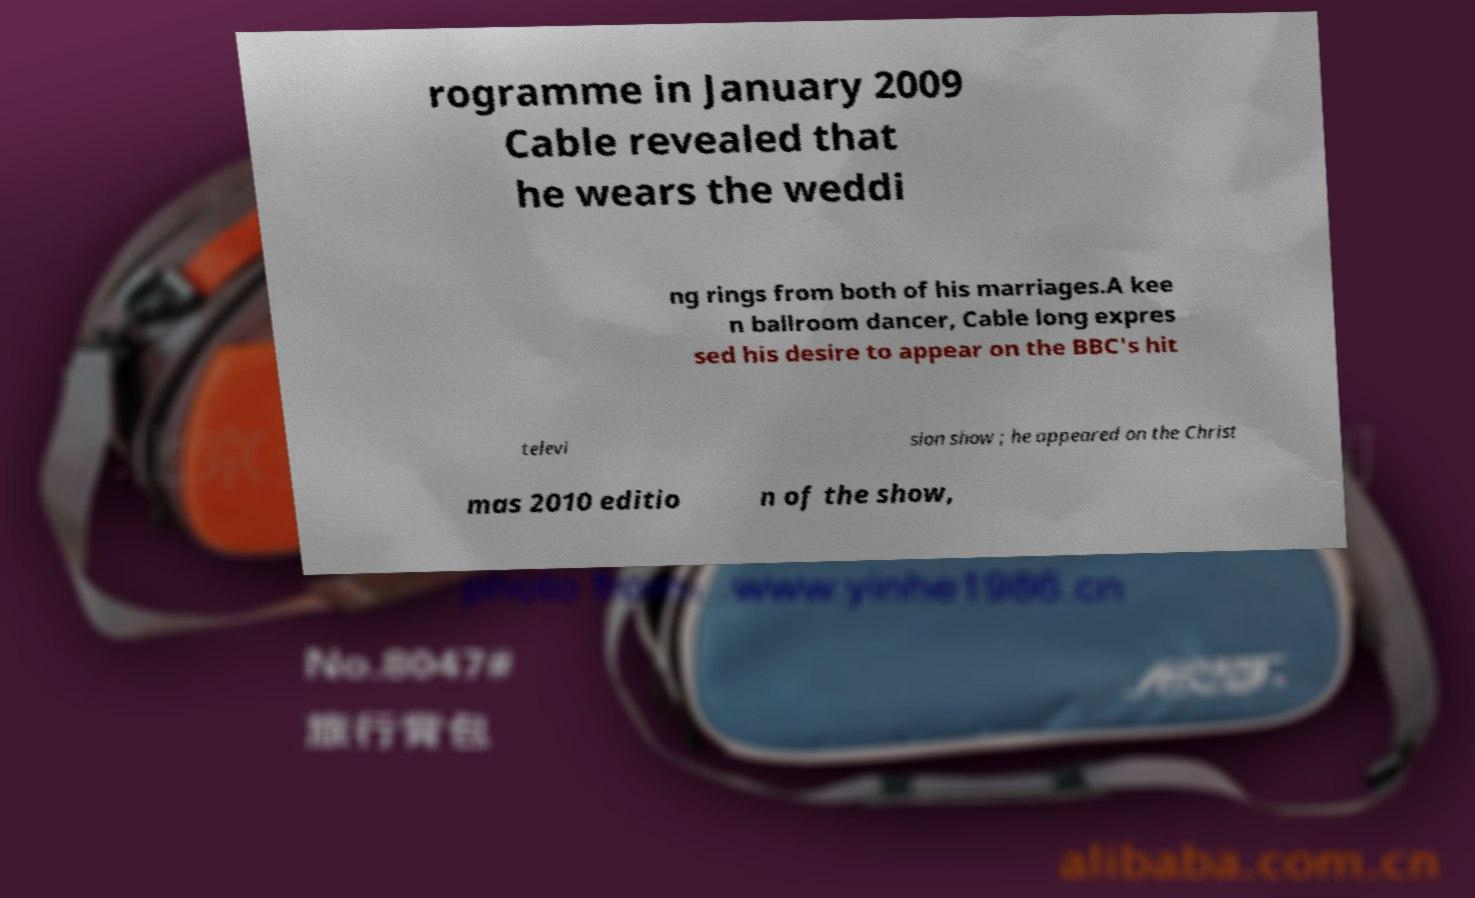Please read and relay the text visible in this image. What does it say? rogramme in January 2009 Cable revealed that he wears the weddi ng rings from both of his marriages.A kee n ballroom dancer, Cable long expres sed his desire to appear on the BBC's hit televi sion show ; he appeared on the Christ mas 2010 editio n of the show, 